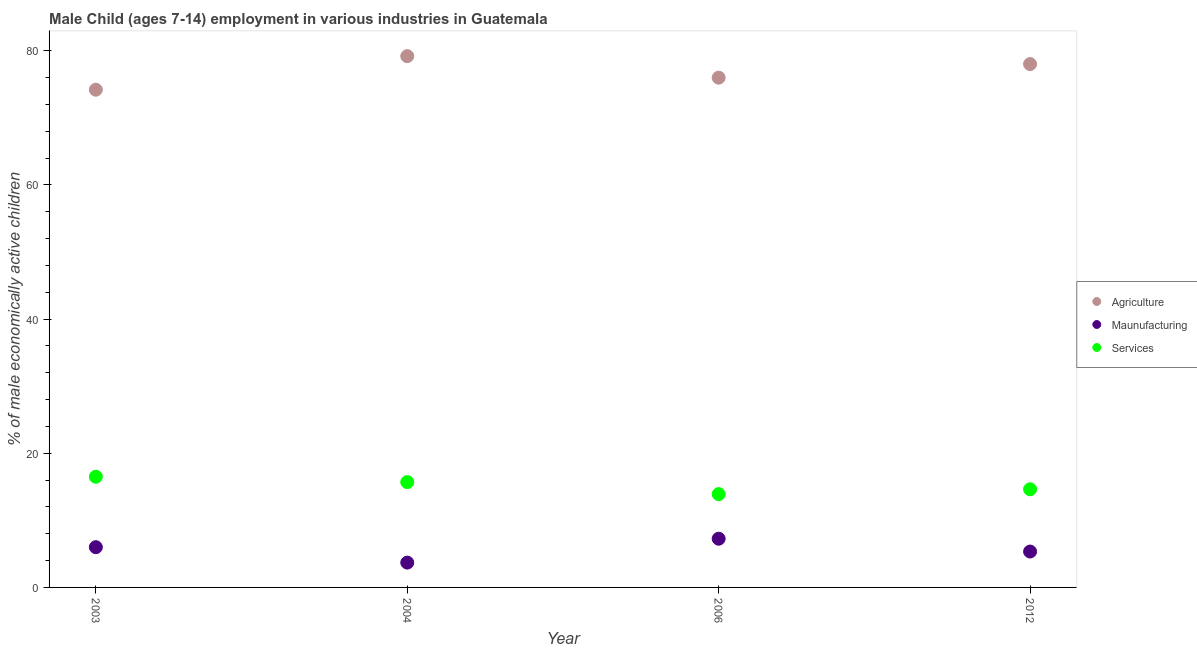Is the number of dotlines equal to the number of legend labels?
Your response must be concise. Yes. What is the percentage of economically active children in manufacturing in 2004?
Offer a terse response. 3.7. Across all years, what is the maximum percentage of economically active children in agriculture?
Make the answer very short. 79.2. Across all years, what is the minimum percentage of economically active children in manufacturing?
Offer a very short reply. 3.7. In which year was the percentage of economically active children in manufacturing maximum?
Provide a succinct answer. 2006. In which year was the percentage of economically active children in agriculture minimum?
Give a very brief answer. 2003. What is the total percentage of economically active children in agriculture in the graph?
Your answer should be compact. 307.41. What is the difference between the percentage of economically active children in manufacturing in 2006 and that in 2012?
Offer a very short reply. 1.91. What is the difference between the percentage of economically active children in agriculture in 2003 and the percentage of economically active children in manufacturing in 2004?
Keep it short and to the point. 70.5. What is the average percentage of economically active children in agriculture per year?
Ensure brevity in your answer.  76.85. In the year 2012, what is the difference between the percentage of economically active children in manufacturing and percentage of economically active children in agriculture?
Give a very brief answer. -72.67. In how many years, is the percentage of economically active children in manufacturing greater than 8 %?
Make the answer very short. 0. What is the ratio of the percentage of economically active children in manufacturing in 2004 to that in 2012?
Your answer should be very brief. 0.69. What is the difference between the highest and the second highest percentage of economically active children in services?
Offer a very short reply. 0.8. What is the difference between the highest and the lowest percentage of economically active children in agriculture?
Keep it short and to the point. 5. In how many years, is the percentage of economically active children in services greater than the average percentage of economically active children in services taken over all years?
Offer a very short reply. 2. Is it the case that in every year, the sum of the percentage of economically active children in agriculture and percentage of economically active children in manufacturing is greater than the percentage of economically active children in services?
Provide a succinct answer. Yes. Does the percentage of economically active children in manufacturing monotonically increase over the years?
Offer a terse response. No. How many dotlines are there?
Make the answer very short. 3. What is the difference between two consecutive major ticks on the Y-axis?
Your answer should be compact. 20. What is the title of the graph?
Offer a very short reply. Male Child (ages 7-14) employment in various industries in Guatemala. What is the label or title of the Y-axis?
Your answer should be very brief. % of male economically active children. What is the % of male economically active children in Agriculture in 2003?
Offer a very short reply. 74.2. What is the % of male economically active children in Maunufacturing in 2003?
Your answer should be compact. 6. What is the % of male economically active children in Services in 2003?
Keep it short and to the point. 16.5. What is the % of male economically active children in Agriculture in 2004?
Offer a very short reply. 79.2. What is the % of male economically active children in Services in 2004?
Give a very brief answer. 15.7. What is the % of male economically active children in Agriculture in 2006?
Provide a succinct answer. 75.99. What is the % of male economically active children in Maunufacturing in 2006?
Your response must be concise. 7.26. What is the % of male economically active children in Services in 2006?
Keep it short and to the point. 13.91. What is the % of male economically active children of Agriculture in 2012?
Give a very brief answer. 78.02. What is the % of male economically active children in Maunufacturing in 2012?
Offer a very short reply. 5.35. What is the % of male economically active children of Services in 2012?
Offer a terse response. 14.63. Across all years, what is the maximum % of male economically active children in Agriculture?
Offer a very short reply. 79.2. Across all years, what is the maximum % of male economically active children in Maunufacturing?
Give a very brief answer. 7.26. Across all years, what is the maximum % of male economically active children in Services?
Provide a short and direct response. 16.5. Across all years, what is the minimum % of male economically active children in Agriculture?
Give a very brief answer. 74.2. Across all years, what is the minimum % of male economically active children of Maunufacturing?
Keep it short and to the point. 3.7. Across all years, what is the minimum % of male economically active children in Services?
Your answer should be compact. 13.91. What is the total % of male economically active children in Agriculture in the graph?
Keep it short and to the point. 307.41. What is the total % of male economically active children of Maunufacturing in the graph?
Your response must be concise. 22.31. What is the total % of male economically active children in Services in the graph?
Offer a terse response. 60.74. What is the difference between the % of male economically active children in Agriculture in 2003 and that in 2004?
Your response must be concise. -5. What is the difference between the % of male economically active children in Maunufacturing in 2003 and that in 2004?
Provide a succinct answer. 2.3. What is the difference between the % of male economically active children of Agriculture in 2003 and that in 2006?
Make the answer very short. -1.79. What is the difference between the % of male economically active children of Maunufacturing in 2003 and that in 2006?
Offer a very short reply. -1.26. What is the difference between the % of male economically active children of Services in 2003 and that in 2006?
Give a very brief answer. 2.59. What is the difference between the % of male economically active children in Agriculture in 2003 and that in 2012?
Offer a terse response. -3.82. What is the difference between the % of male economically active children of Maunufacturing in 2003 and that in 2012?
Offer a very short reply. 0.65. What is the difference between the % of male economically active children in Services in 2003 and that in 2012?
Keep it short and to the point. 1.87. What is the difference between the % of male economically active children of Agriculture in 2004 and that in 2006?
Give a very brief answer. 3.21. What is the difference between the % of male economically active children in Maunufacturing in 2004 and that in 2006?
Give a very brief answer. -3.56. What is the difference between the % of male economically active children of Services in 2004 and that in 2006?
Offer a terse response. 1.79. What is the difference between the % of male economically active children in Agriculture in 2004 and that in 2012?
Give a very brief answer. 1.18. What is the difference between the % of male economically active children of Maunufacturing in 2004 and that in 2012?
Ensure brevity in your answer.  -1.65. What is the difference between the % of male economically active children of Services in 2004 and that in 2012?
Give a very brief answer. 1.07. What is the difference between the % of male economically active children of Agriculture in 2006 and that in 2012?
Keep it short and to the point. -2.03. What is the difference between the % of male economically active children of Maunufacturing in 2006 and that in 2012?
Your answer should be compact. 1.91. What is the difference between the % of male economically active children of Services in 2006 and that in 2012?
Your response must be concise. -0.72. What is the difference between the % of male economically active children in Agriculture in 2003 and the % of male economically active children in Maunufacturing in 2004?
Provide a short and direct response. 70.5. What is the difference between the % of male economically active children in Agriculture in 2003 and the % of male economically active children in Services in 2004?
Give a very brief answer. 58.5. What is the difference between the % of male economically active children in Maunufacturing in 2003 and the % of male economically active children in Services in 2004?
Provide a short and direct response. -9.7. What is the difference between the % of male economically active children of Agriculture in 2003 and the % of male economically active children of Maunufacturing in 2006?
Your answer should be compact. 66.94. What is the difference between the % of male economically active children of Agriculture in 2003 and the % of male economically active children of Services in 2006?
Provide a succinct answer. 60.29. What is the difference between the % of male economically active children in Maunufacturing in 2003 and the % of male economically active children in Services in 2006?
Offer a terse response. -7.91. What is the difference between the % of male economically active children of Agriculture in 2003 and the % of male economically active children of Maunufacturing in 2012?
Provide a succinct answer. 68.85. What is the difference between the % of male economically active children in Agriculture in 2003 and the % of male economically active children in Services in 2012?
Your response must be concise. 59.57. What is the difference between the % of male economically active children in Maunufacturing in 2003 and the % of male economically active children in Services in 2012?
Offer a terse response. -8.63. What is the difference between the % of male economically active children of Agriculture in 2004 and the % of male economically active children of Maunufacturing in 2006?
Your response must be concise. 71.94. What is the difference between the % of male economically active children of Agriculture in 2004 and the % of male economically active children of Services in 2006?
Your answer should be compact. 65.29. What is the difference between the % of male economically active children of Maunufacturing in 2004 and the % of male economically active children of Services in 2006?
Make the answer very short. -10.21. What is the difference between the % of male economically active children in Agriculture in 2004 and the % of male economically active children in Maunufacturing in 2012?
Give a very brief answer. 73.85. What is the difference between the % of male economically active children of Agriculture in 2004 and the % of male economically active children of Services in 2012?
Give a very brief answer. 64.57. What is the difference between the % of male economically active children of Maunufacturing in 2004 and the % of male economically active children of Services in 2012?
Make the answer very short. -10.93. What is the difference between the % of male economically active children of Agriculture in 2006 and the % of male economically active children of Maunufacturing in 2012?
Your answer should be compact. 70.64. What is the difference between the % of male economically active children in Agriculture in 2006 and the % of male economically active children in Services in 2012?
Provide a succinct answer. 61.36. What is the difference between the % of male economically active children in Maunufacturing in 2006 and the % of male economically active children in Services in 2012?
Give a very brief answer. -7.37. What is the average % of male economically active children in Agriculture per year?
Ensure brevity in your answer.  76.85. What is the average % of male economically active children in Maunufacturing per year?
Ensure brevity in your answer.  5.58. What is the average % of male economically active children in Services per year?
Your answer should be very brief. 15.19. In the year 2003, what is the difference between the % of male economically active children in Agriculture and % of male economically active children in Maunufacturing?
Provide a succinct answer. 68.2. In the year 2003, what is the difference between the % of male economically active children of Agriculture and % of male economically active children of Services?
Make the answer very short. 57.7. In the year 2004, what is the difference between the % of male economically active children of Agriculture and % of male economically active children of Maunufacturing?
Provide a succinct answer. 75.5. In the year 2004, what is the difference between the % of male economically active children in Agriculture and % of male economically active children in Services?
Provide a succinct answer. 63.5. In the year 2006, what is the difference between the % of male economically active children of Agriculture and % of male economically active children of Maunufacturing?
Keep it short and to the point. 68.73. In the year 2006, what is the difference between the % of male economically active children in Agriculture and % of male economically active children in Services?
Make the answer very short. 62.08. In the year 2006, what is the difference between the % of male economically active children of Maunufacturing and % of male economically active children of Services?
Your answer should be very brief. -6.65. In the year 2012, what is the difference between the % of male economically active children in Agriculture and % of male economically active children in Maunufacturing?
Your answer should be compact. 72.67. In the year 2012, what is the difference between the % of male economically active children in Agriculture and % of male economically active children in Services?
Make the answer very short. 63.39. In the year 2012, what is the difference between the % of male economically active children of Maunufacturing and % of male economically active children of Services?
Offer a terse response. -9.28. What is the ratio of the % of male economically active children in Agriculture in 2003 to that in 2004?
Offer a terse response. 0.94. What is the ratio of the % of male economically active children of Maunufacturing in 2003 to that in 2004?
Your answer should be compact. 1.62. What is the ratio of the % of male economically active children of Services in 2003 to that in 2004?
Provide a short and direct response. 1.05. What is the ratio of the % of male economically active children in Agriculture in 2003 to that in 2006?
Keep it short and to the point. 0.98. What is the ratio of the % of male economically active children of Maunufacturing in 2003 to that in 2006?
Your response must be concise. 0.83. What is the ratio of the % of male economically active children of Services in 2003 to that in 2006?
Keep it short and to the point. 1.19. What is the ratio of the % of male economically active children in Agriculture in 2003 to that in 2012?
Provide a succinct answer. 0.95. What is the ratio of the % of male economically active children of Maunufacturing in 2003 to that in 2012?
Keep it short and to the point. 1.12. What is the ratio of the % of male economically active children in Services in 2003 to that in 2012?
Your answer should be compact. 1.13. What is the ratio of the % of male economically active children in Agriculture in 2004 to that in 2006?
Offer a terse response. 1.04. What is the ratio of the % of male economically active children of Maunufacturing in 2004 to that in 2006?
Your response must be concise. 0.51. What is the ratio of the % of male economically active children in Services in 2004 to that in 2006?
Your response must be concise. 1.13. What is the ratio of the % of male economically active children of Agriculture in 2004 to that in 2012?
Offer a very short reply. 1.02. What is the ratio of the % of male economically active children in Maunufacturing in 2004 to that in 2012?
Keep it short and to the point. 0.69. What is the ratio of the % of male economically active children of Services in 2004 to that in 2012?
Keep it short and to the point. 1.07. What is the ratio of the % of male economically active children in Maunufacturing in 2006 to that in 2012?
Your answer should be compact. 1.36. What is the ratio of the % of male economically active children of Services in 2006 to that in 2012?
Offer a terse response. 0.95. What is the difference between the highest and the second highest % of male economically active children in Agriculture?
Your answer should be very brief. 1.18. What is the difference between the highest and the second highest % of male economically active children of Maunufacturing?
Offer a terse response. 1.26. What is the difference between the highest and the second highest % of male economically active children of Services?
Provide a short and direct response. 0.8. What is the difference between the highest and the lowest % of male economically active children in Maunufacturing?
Offer a terse response. 3.56. What is the difference between the highest and the lowest % of male economically active children in Services?
Offer a very short reply. 2.59. 